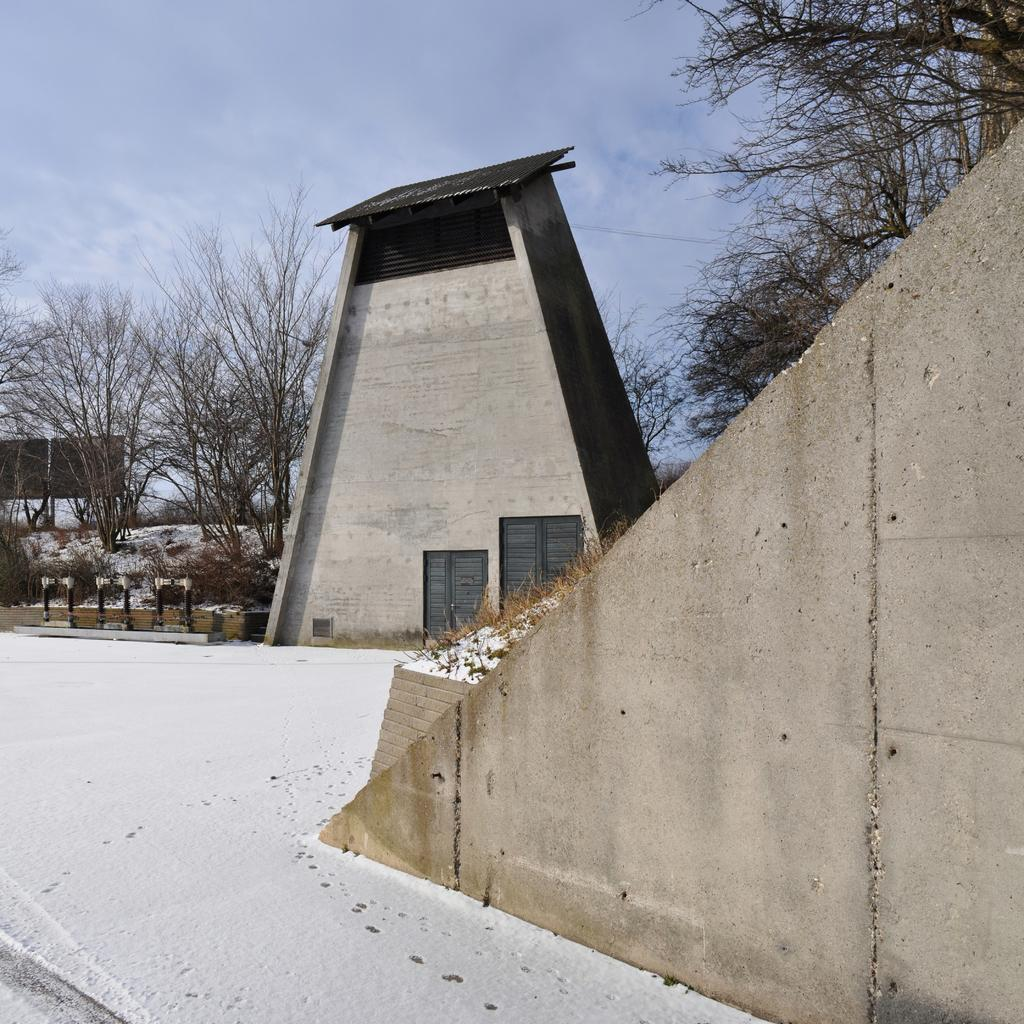What is one of the main features in the image? There is a wall in the image. What is the condition of the road in the image? There is snow on the road in the image. What type of structure can be seen in the image? There is an architecture building in the image. What type of vegetation is present in the image? There are trees in the image. What is the object on the wall in the image? There is a board in the image. What is visible in the background of the image? The sky is visible in the background of the image. What can be observed in the sky? Clouds are present in the sky. What type of thunder can be heard in the image? There is no sound present in the image, so it is not possible to determine if thunder can be heard. 